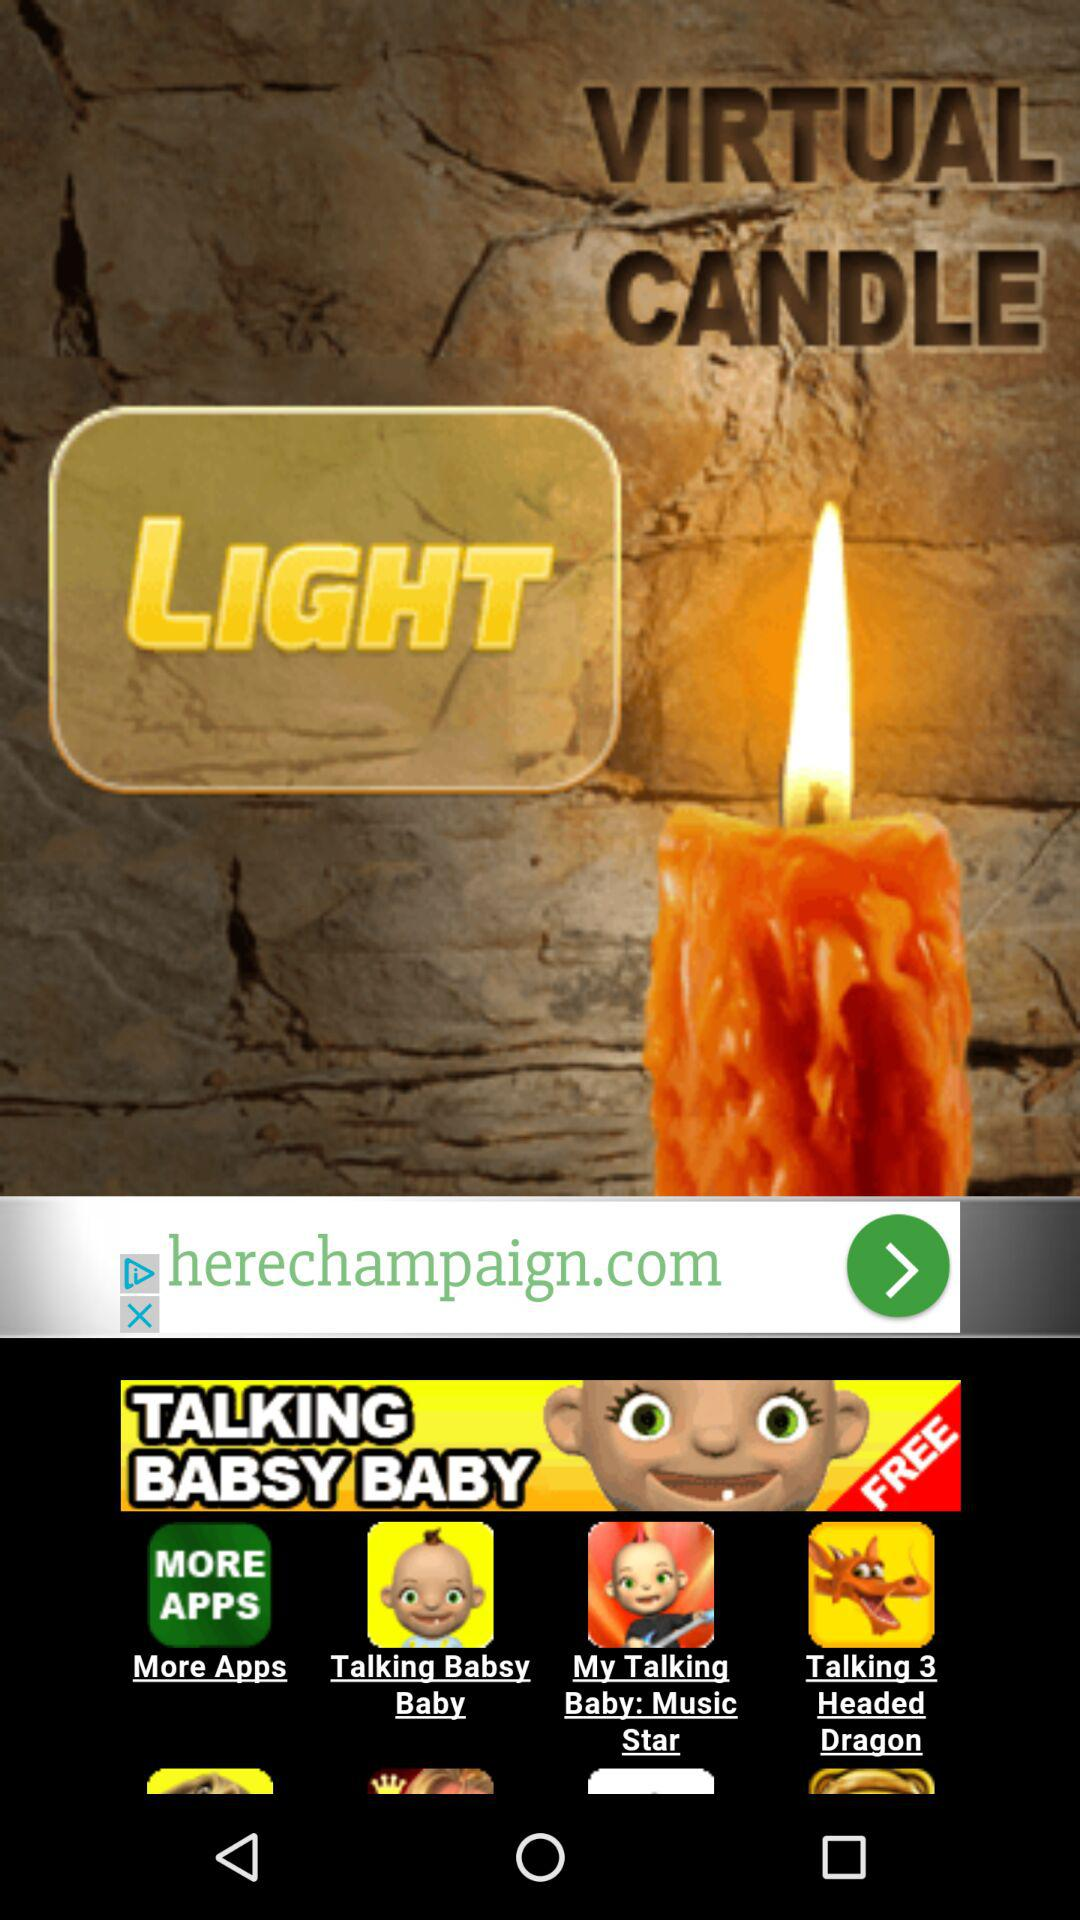What is the name of the application? The name of the application is "VIRTUAL CANDLE". 